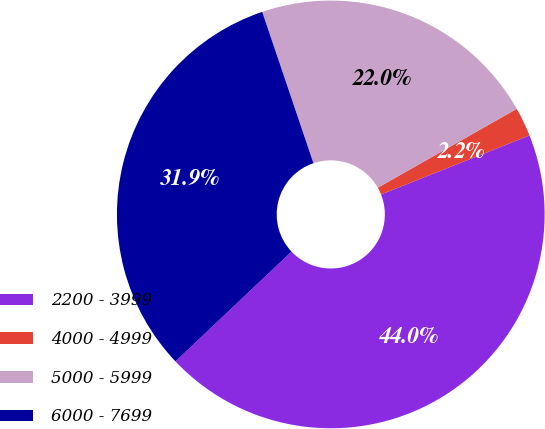Convert chart to OTSL. <chart><loc_0><loc_0><loc_500><loc_500><pie_chart><fcel>2200 - 3999<fcel>4000 - 4999<fcel>5000 - 5999<fcel>6000 - 7699<nl><fcel>43.96%<fcel>2.2%<fcel>21.98%<fcel>31.87%<nl></chart> 